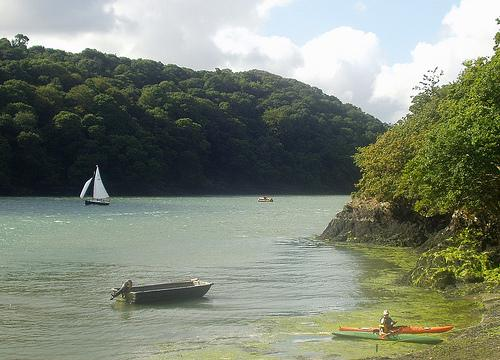In the referential expression grounding task, outline the position of the sailboat with a white sail relative to others in the image. The sailboat with a white sail is located towards the top-left section of the image. Create a catchy slogan for a product advertisement featuring the person in the orange boat. "Adventure Awaits You - Go Beyond with Our Orange Kayaks!" List the different types of boats depicted in the image for the multi-choice VQA task. There is a sailboat, a motorboat, an orange kayak, a green kayak, and a small yellow raft. Describe the state of the water, based on visual entailment. The water is mostly calm, with some areas containing murky green algae. Comment on the overall setting and environment of the image for the visual entailment task. The image takes place in a serene body of water surrounded by lush greenery and a cloudy blue sky above. For the multi-choice VQA task, identify which watercraft appears the smallest in the image. The smallest watercraft is the tiny boat in the distance. Choose a suitable background score for a product advertisement featuring the sailboats and kayaks on the water. "Ambient acoustic guitar with soft, gentle ocean waves." For the multi-choice VQA task, describe what color is the kayak next to the motorboat. The kayak next to the motorboat is orange. In the referential expression grounding task, pinpoint where the person wearing the tan hat is located. The person wearing the tan hat is in the orange boat. In the visual entailment task, determine whether the small yellow raft has made contact with the water or not. Yes, the small yellow raft is in the water. 